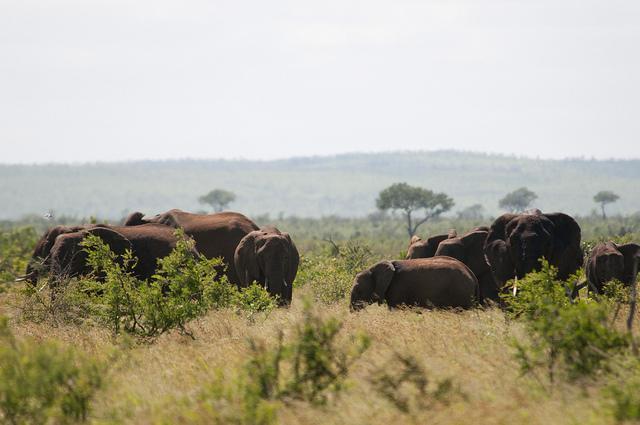How many elephants can be seen?
Give a very brief answer. 6. 